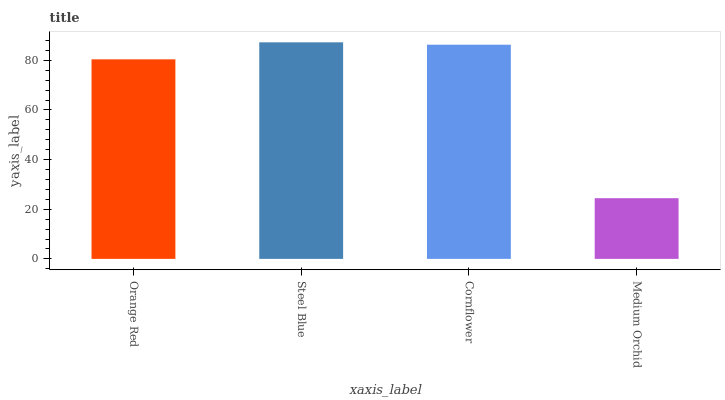Is Medium Orchid the minimum?
Answer yes or no. Yes. Is Steel Blue the maximum?
Answer yes or no. Yes. Is Cornflower the minimum?
Answer yes or no. No. Is Cornflower the maximum?
Answer yes or no. No. Is Steel Blue greater than Cornflower?
Answer yes or no. Yes. Is Cornflower less than Steel Blue?
Answer yes or no. Yes. Is Cornflower greater than Steel Blue?
Answer yes or no. No. Is Steel Blue less than Cornflower?
Answer yes or no. No. Is Cornflower the high median?
Answer yes or no. Yes. Is Orange Red the low median?
Answer yes or no. Yes. Is Orange Red the high median?
Answer yes or no. No. Is Cornflower the low median?
Answer yes or no. No. 